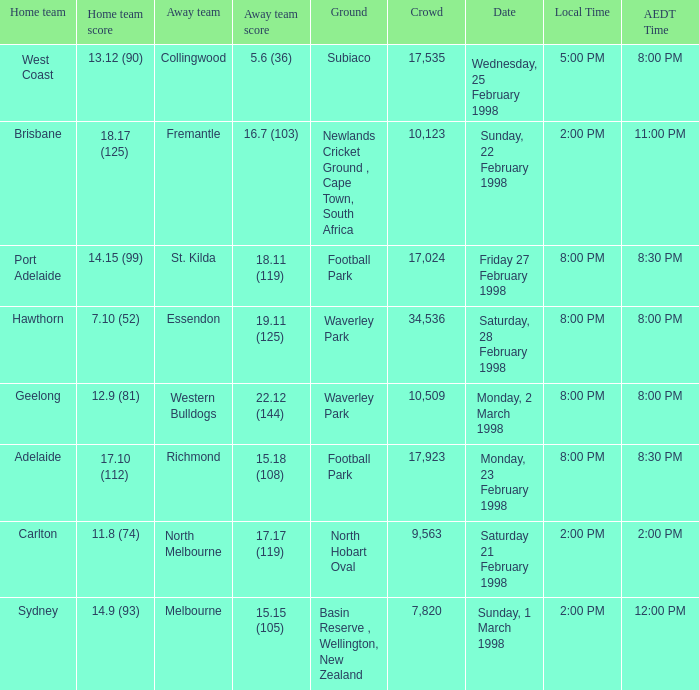Which Home team is on Wednesday, 25 february 1998? West Coast. 